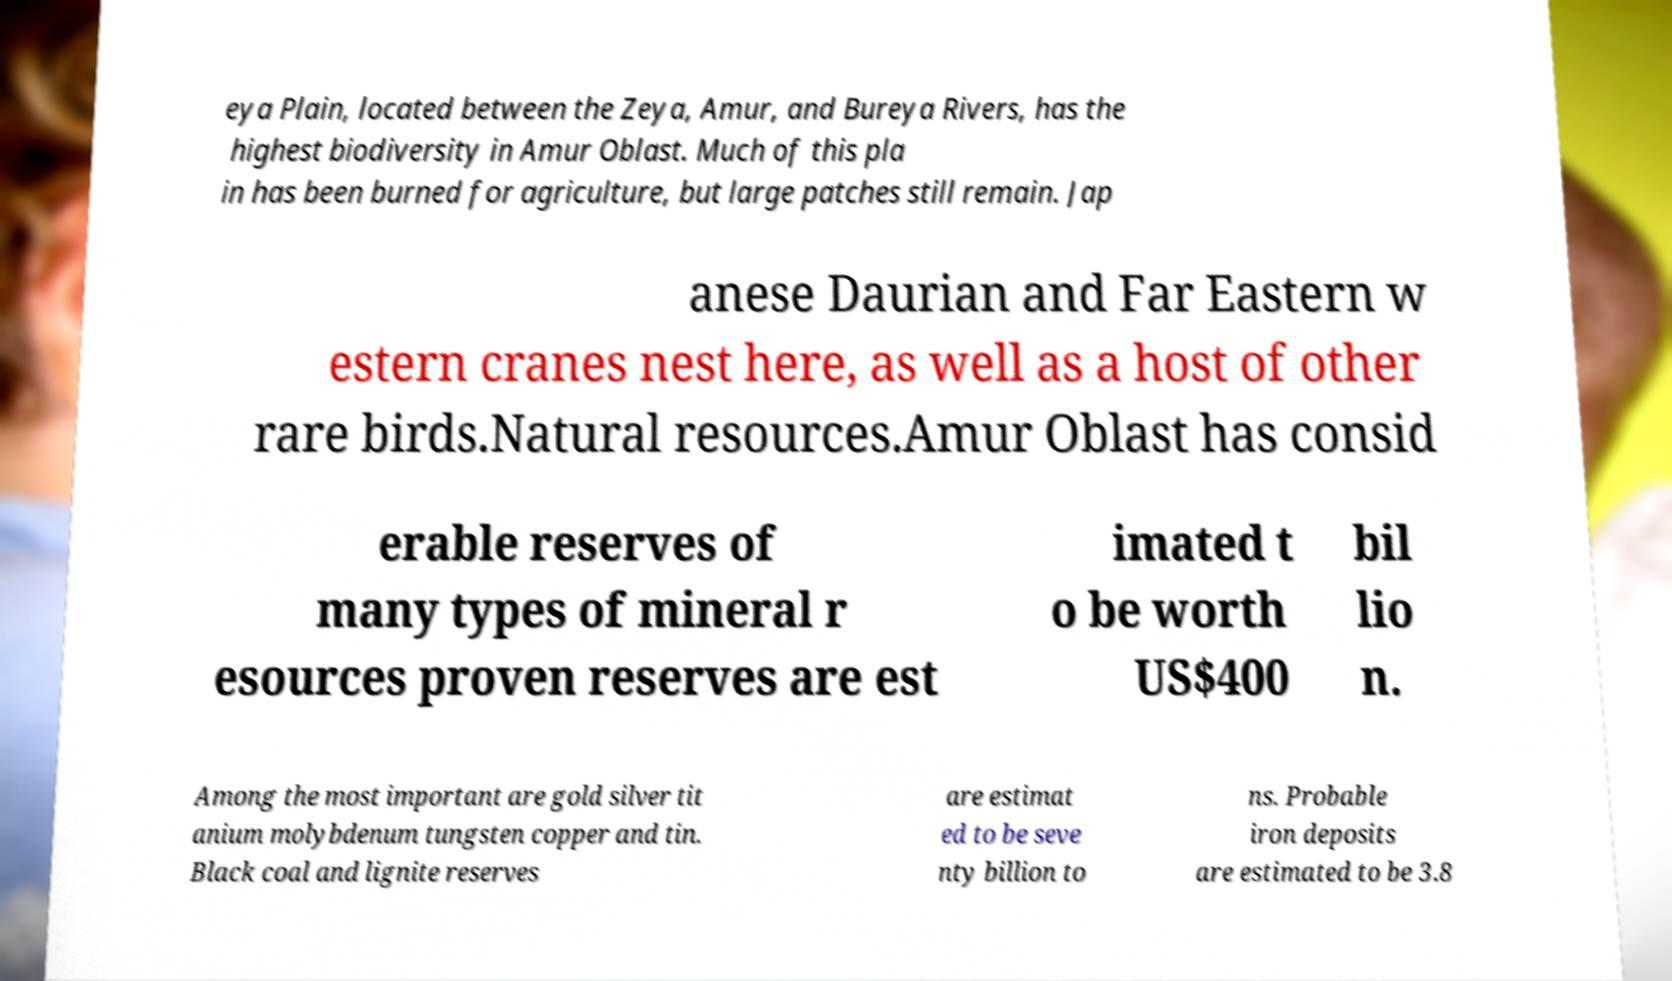Please identify and transcribe the text found in this image. eya Plain, located between the Zeya, Amur, and Bureya Rivers, has the highest biodiversity in Amur Oblast. Much of this pla in has been burned for agriculture, but large patches still remain. Jap anese Daurian and Far Eastern w estern cranes nest here, as well as a host of other rare birds.Natural resources.Amur Oblast has consid erable reserves of many types of mineral r esources proven reserves are est imated t o be worth US$400 bil lio n. Among the most important are gold silver tit anium molybdenum tungsten copper and tin. Black coal and lignite reserves are estimat ed to be seve nty billion to ns. Probable iron deposits are estimated to be 3.8 